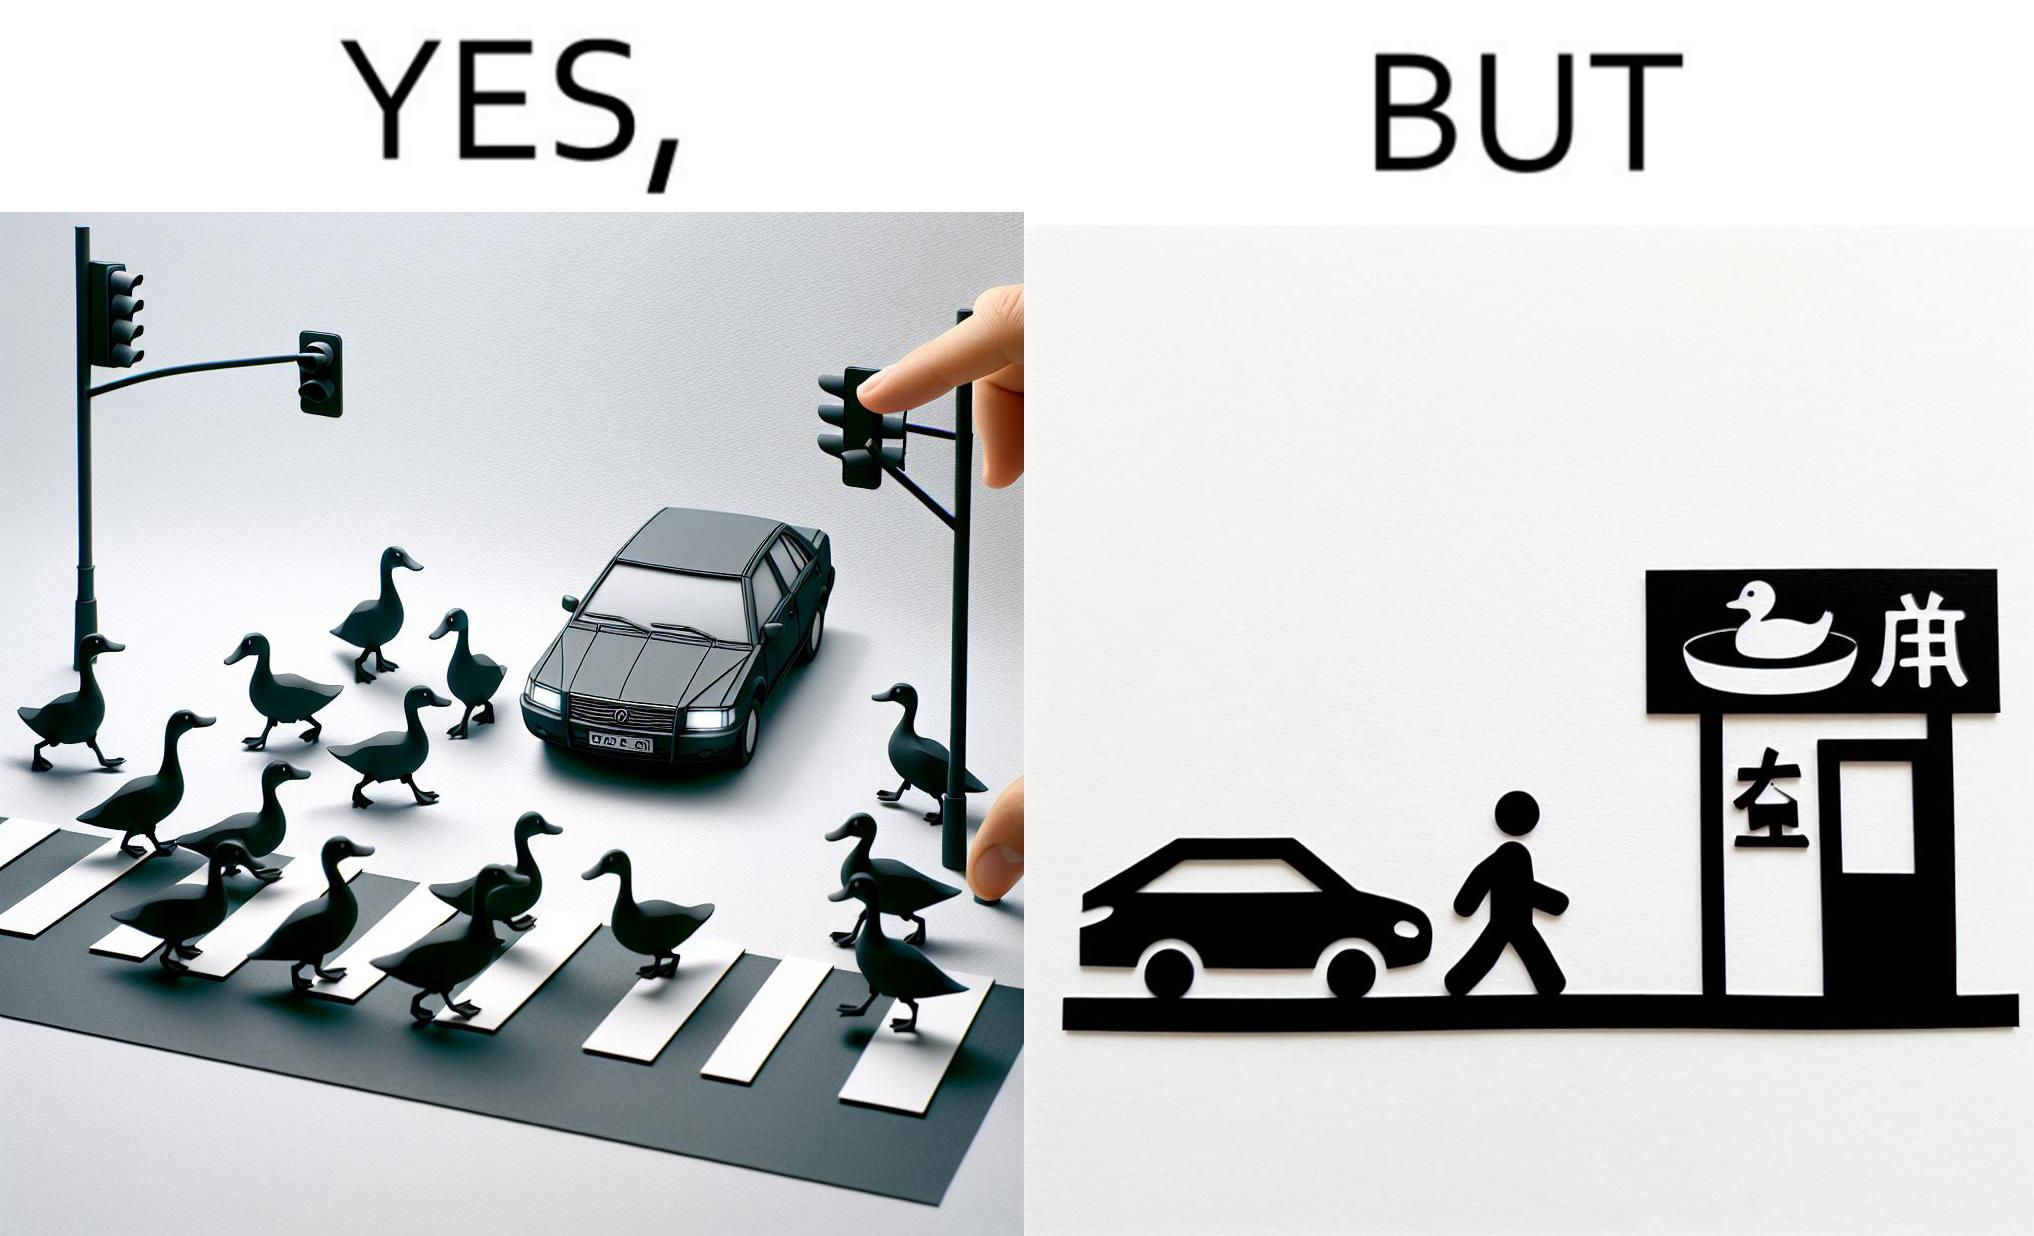Describe what you see in this image. The images are ironic since they show how a man supposedly cares for ducks since he stops his vehicle to give way to queue of ducks allowing them to safely cross a road but on the other hand he goes to a peking duck shop to buy and eat similar ducks after having them killed 